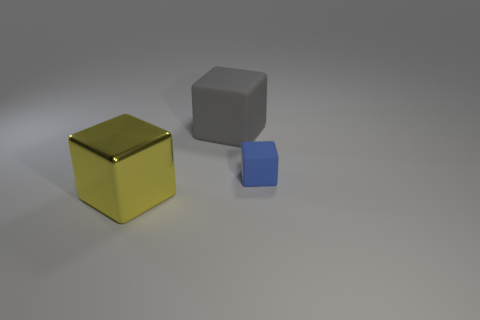Subtract all rubber blocks. How many blocks are left? 1 Subtract all yellow blocks. How many blocks are left? 2 Subtract 3 cubes. How many cubes are left? 0 Add 1 rubber objects. How many objects exist? 4 Subtract 1 blue blocks. How many objects are left? 2 Subtract all cyan cubes. Subtract all purple cylinders. How many cubes are left? 3 Subtract all gray matte blocks. Subtract all gray objects. How many objects are left? 1 Add 1 large gray rubber objects. How many large gray rubber objects are left? 2 Add 1 tiny matte things. How many tiny matte things exist? 2 